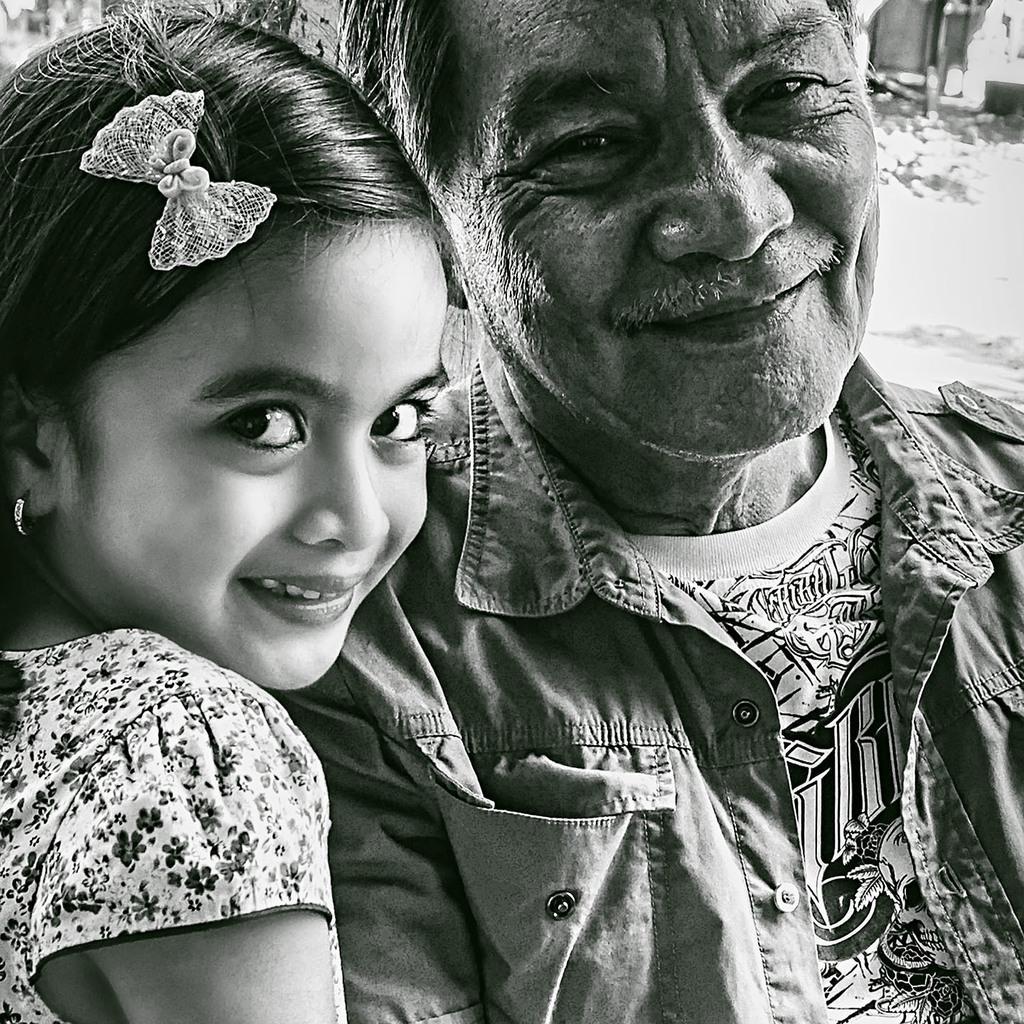Could you give a brief overview of what you see in this image? There is a man and child wearing clothes. 